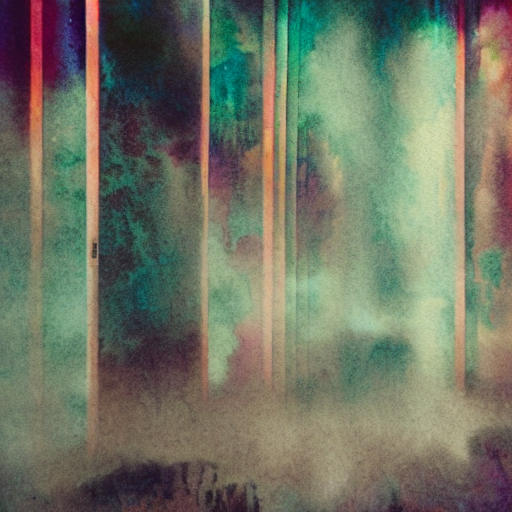How would you rate the image quality?
A. Very poor.
B. Excellent
C. Outstanding
Answer with the option's letter from the given choices directly. While I can't provide subjective opinions, the image appears to exhibit qualities that may not meet conventional high standards due to its blurred and abstract nature. Depending on the artistic intent, it can be seen as expressive. Judging strictly by technical standards such as sharpness and clarity, one might lean towards option A, 'Very poor.' However, in an artistic context, its quality could be considered compelling and mood-evoking. 